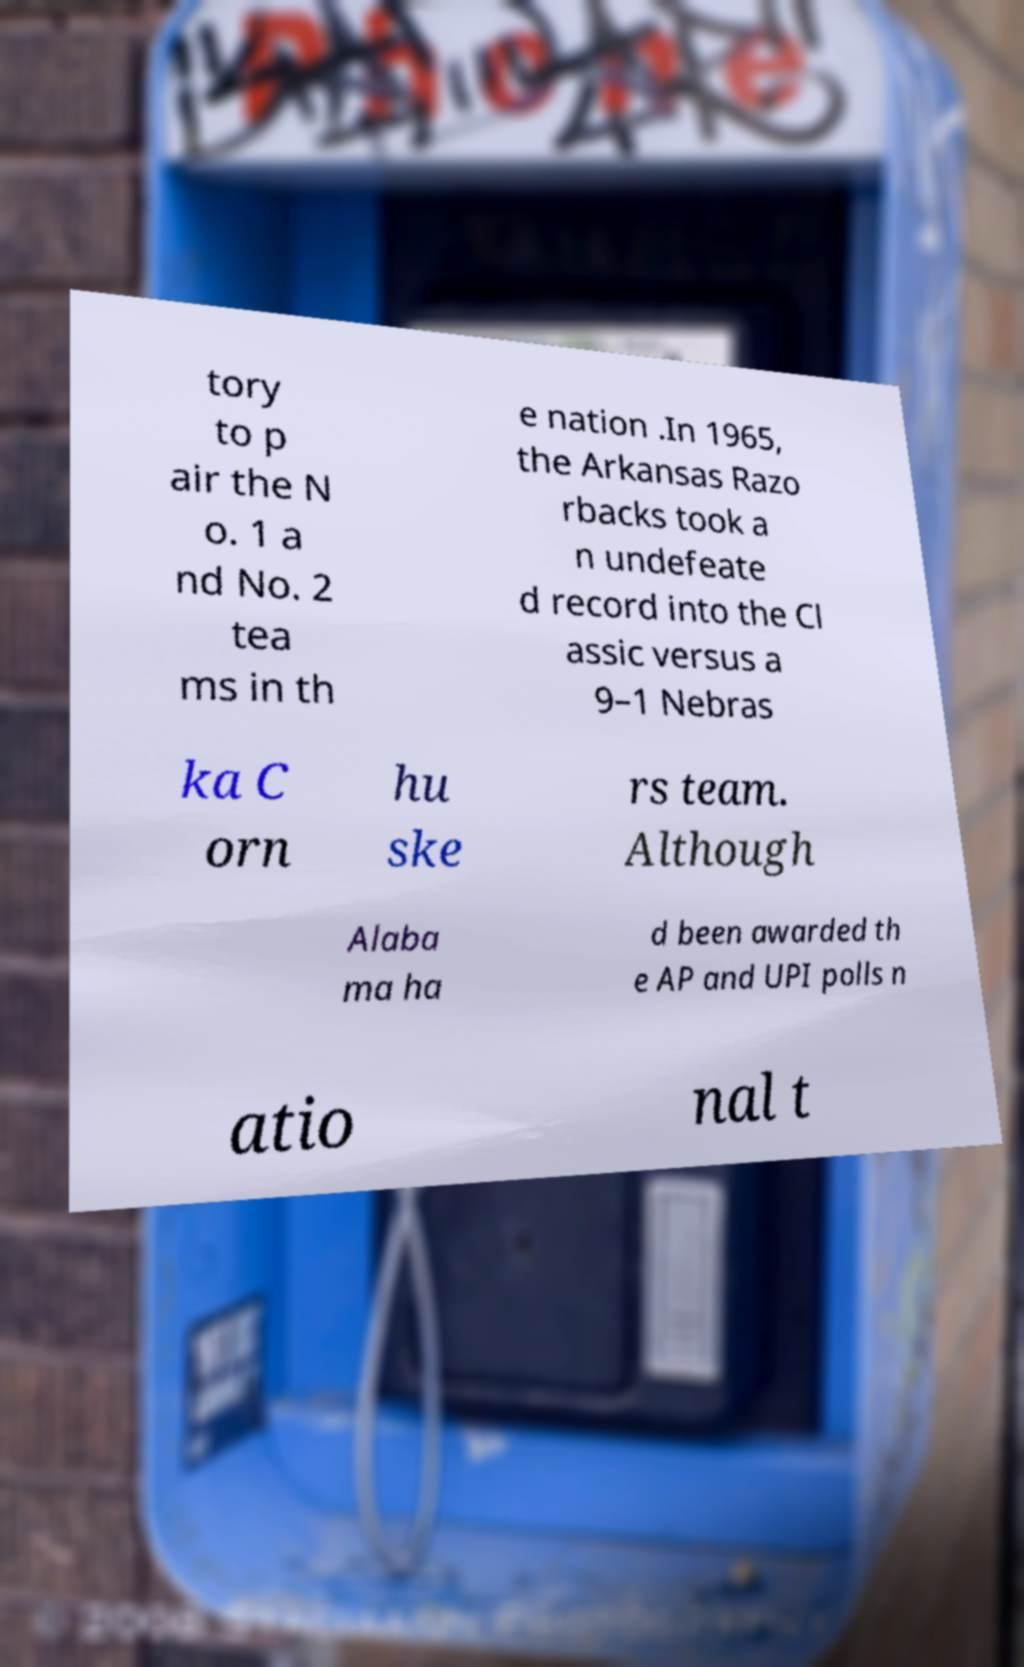There's text embedded in this image that I need extracted. Can you transcribe it verbatim? tory to p air the N o. 1 a nd No. 2 tea ms in th e nation .In 1965, the Arkansas Razo rbacks took a n undefeate d record into the Cl assic versus a 9–1 Nebras ka C orn hu ske rs team. Although Alaba ma ha d been awarded th e AP and UPI polls n atio nal t 